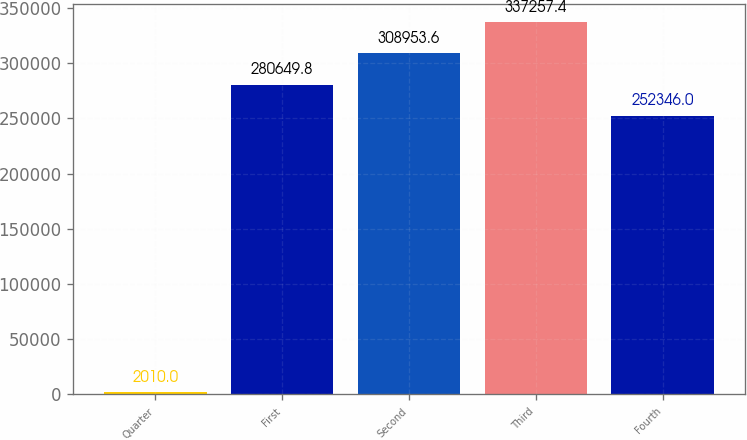<chart> <loc_0><loc_0><loc_500><loc_500><bar_chart><fcel>Quarter<fcel>First<fcel>Second<fcel>Third<fcel>Fourth<nl><fcel>2010<fcel>280650<fcel>308954<fcel>337257<fcel>252346<nl></chart> 